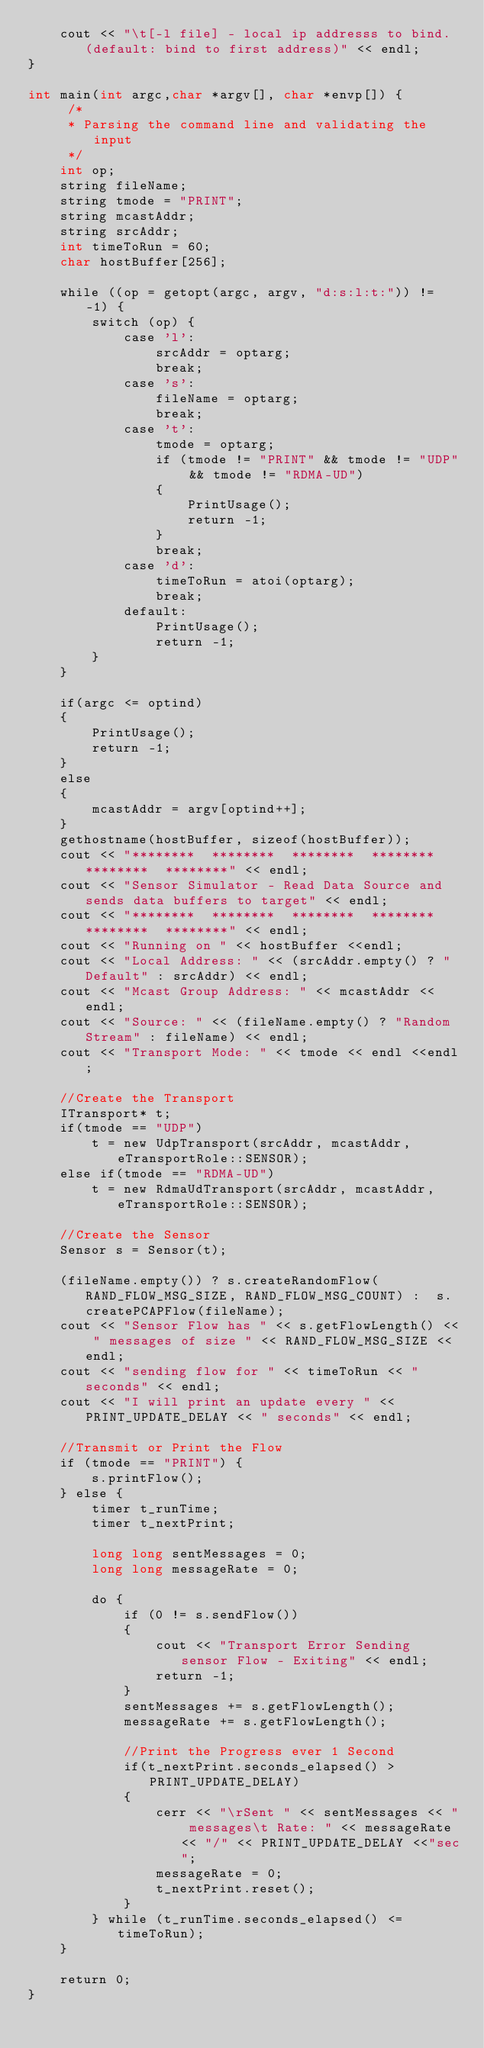Convert code to text. <code><loc_0><loc_0><loc_500><loc_500><_Cuda_>    cout << "\t[-l file] - local ip addresss to bind. (default: bind to first address)" << endl;
}

int main(int argc,char *argv[], char *envp[]) {
     /*
     * Parsing the command line and validating the input
     */
    int op;
    string fileName;
    string tmode = "PRINT";
    string mcastAddr;
    string srcAddr;
    int timeToRun = 60;
    char hostBuffer[256];

    while ((op = getopt(argc, argv, "d:s:l:t:")) != -1) {
        switch (op) {
            case 'l':
                srcAddr = optarg;
                break;
            case 's':
                fileName = optarg;
                break;
            case 't':
                tmode = optarg;
                if (tmode != "PRINT" && tmode != "UDP" && tmode != "RDMA-UD")
                {
                    PrintUsage();
                    return -1;
                }
                break;
            case 'd':
                timeToRun = atoi(optarg);
                break;
            default:
                PrintUsage();
                return -1;
        }
    }

    if(argc <= optind)
    {
        PrintUsage();
        return -1;
    }
    else
    {
        mcastAddr = argv[optind++];
    }
    gethostname(hostBuffer, sizeof(hostBuffer));
    cout << "********  ********  ********  ********  ********  ********" << endl;
    cout << "Sensor Simulator - Read Data Source and sends data buffers to target" << endl;
    cout << "********  ********  ********  ********  ********  ********" << endl;
    cout << "Running on " << hostBuffer <<endl;
    cout << "Local Address: " << (srcAddr.empty() ? "Default" : srcAddr) << endl;
    cout << "Mcast Group Address: " << mcastAddr << endl;
    cout << "Source: " << (fileName.empty() ? "Random Stream" : fileName) << endl;
    cout << "Transport Mode: " << tmode << endl <<endl;

    //Create the Transport
    ITransport* t;
    if(tmode == "UDP")
        t = new UdpTransport(srcAddr, mcastAddr, eTransportRole::SENSOR);
    else if(tmode == "RDMA-UD")
        t = new RdmaUdTransport(srcAddr, mcastAddr, eTransportRole::SENSOR);

    //Create the Sensor
    Sensor s = Sensor(t);

    (fileName.empty()) ? s.createRandomFlow(RAND_FLOW_MSG_SIZE, RAND_FLOW_MSG_COUNT) :  s.createPCAPFlow(fileName);
    cout << "Sensor Flow has " << s.getFlowLength() << " messages of size " << RAND_FLOW_MSG_SIZE << endl;
    cout << "sending flow for " << timeToRun << " seconds" << endl;
    cout << "I will print an update every " << PRINT_UPDATE_DELAY << " seconds" << endl;

    //Transmit or Print the Flow
    if (tmode == "PRINT") {
        s.printFlow();
    } else {
        timer t_runTime;
        timer t_nextPrint;

        long long sentMessages = 0;
        long long messageRate = 0;

        do {
            if (0 != s.sendFlow())
            {
                cout << "Transport Error Sending sensor Flow - Exiting" << endl;
                return -1;
            }
            sentMessages += s.getFlowLength();
            messageRate += s.getFlowLength();

            //Print the Progress ever 1 Second
            if(t_nextPrint.seconds_elapsed() > PRINT_UPDATE_DELAY)
            {
                cerr << "\rSent " << sentMessages << " messages\t Rate: " << messageRate << "/" << PRINT_UPDATE_DELAY <<"sec";
                messageRate = 0;
                t_nextPrint.reset();
            }
        } while (t_runTime.seconds_elapsed() <= timeToRun);
    }

    return 0;
}
</code> 